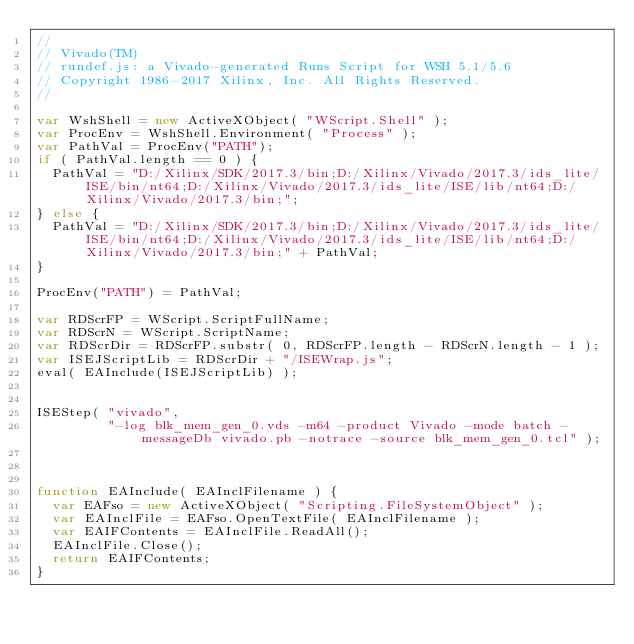<code> <loc_0><loc_0><loc_500><loc_500><_JavaScript_>//
// Vivado(TM)
// rundef.js: a Vivado-generated Runs Script for WSH 5.1/5.6
// Copyright 1986-2017 Xilinx, Inc. All Rights Reserved.
//

var WshShell = new ActiveXObject( "WScript.Shell" );
var ProcEnv = WshShell.Environment( "Process" );
var PathVal = ProcEnv("PATH");
if ( PathVal.length == 0 ) {
  PathVal = "D:/Xilinx/SDK/2017.3/bin;D:/Xilinx/Vivado/2017.3/ids_lite/ISE/bin/nt64;D:/Xilinx/Vivado/2017.3/ids_lite/ISE/lib/nt64;D:/Xilinx/Vivado/2017.3/bin;";
} else {
  PathVal = "D:/Xilinx/SDK/2017.3/bin;D:/Xilinx/Vivado/2017.3/ids_lite/ISE/bin/nt64;D:/Xilinx/Vivado/2017.3/ids_lite/ISE/lib/nt64;D:/Xilinx/Vivado/2017.3/bin;" + PathVal;
}

ProcEnv("PATH") = PathVal;

var RDScrFP = WScript.ScriptFullName;
var RDScrN = WScript.ScriptName;
var RDScrDir = RDScrFP.substr( 0, RDScrFP.length - RDScrN.length - 1 );
var ISEJScriptLib = RDScrDir + "/ISEWrap.js";
eval( EAInclude(ISEJScriptLib) );


ISEStep( "vivado",
         "-log blk_mem_gen_0.vds -m64 -product Vivado -mode batch -messageDb vivado.pb -notrace -source blk_mem_gen_0.tcl" );



function EAInclude( EAInclFilename ) {
  var EAFso = new ActiveXObject( "Scripting.FileSystemObject" );
  var EAInclFile = EAFso.OpenTextFile( EAInclFilename );
  var EAIFContents = EAInclFile.ReadAll();
  EAInclFile.Close();
  return EAIFContents;
}
</code> 